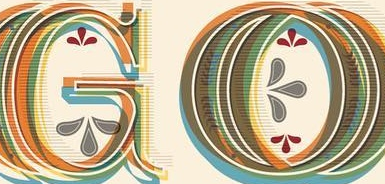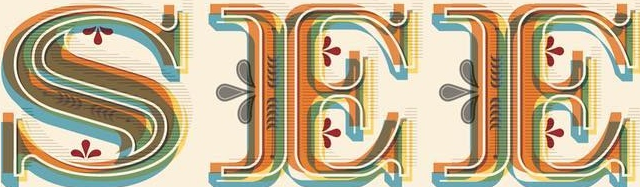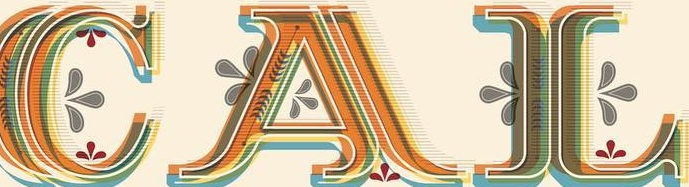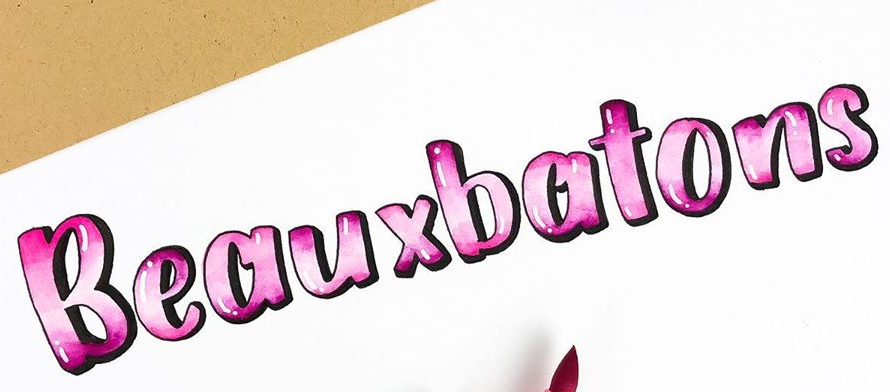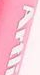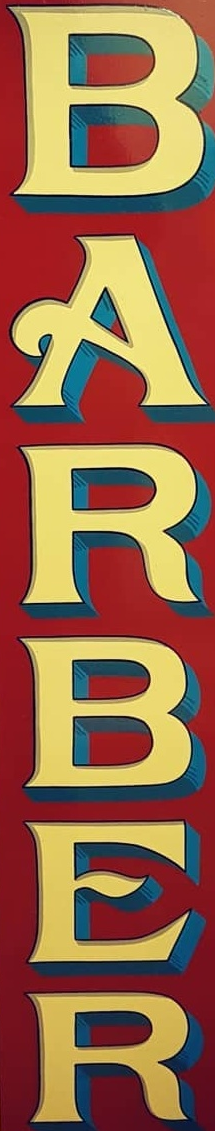What words are shown in these images in order, separated by a semicolon? GO; SEE; CAL; Beauxbatons; Artli; BARBER 